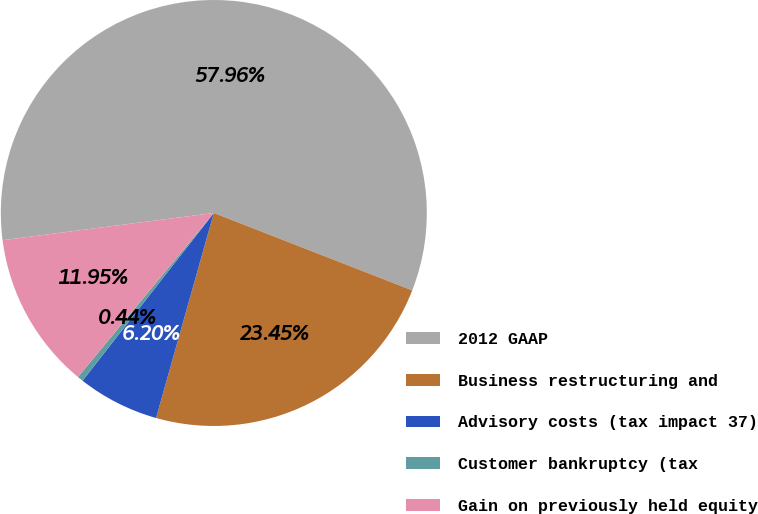Convert chart. <chart><loc_0><loc_0><loc_500><loc_500><pie_chart><fcel>2012 GAAP<fcel>Business restructuring and<fcel>Advisory costs (tax impact 37)<fcel>Customer bankruptcy (tax<fcel>Gain on previously held equity<nl><fcel>57.96%<fcel>23.45%<fcel>6.2%<fcel>0.44%<fcel>11.95%<nl></chart> 